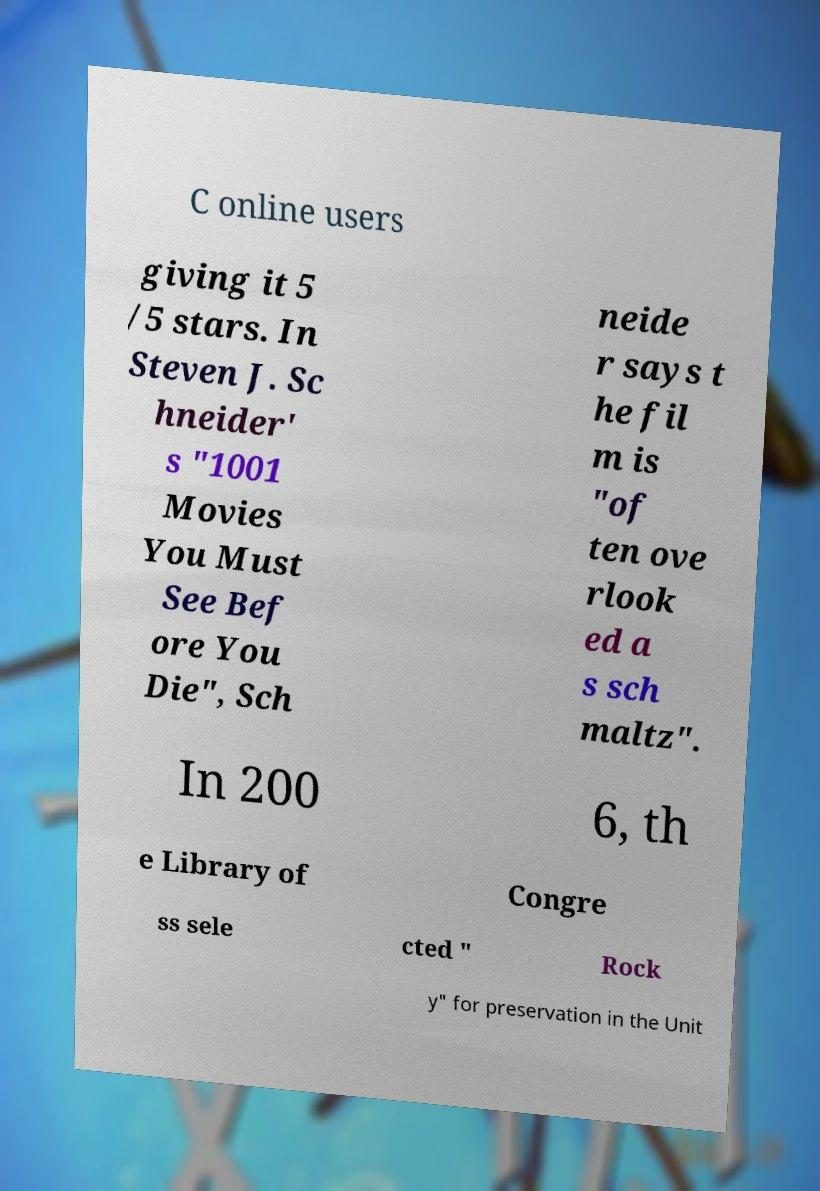There's text embedded in this image that I need extracted. Can you transcribe it verbatim? C online users giving it 5 /5 stars. In Steven J. Sc hneider' s "1001 Movies You Must See Bef ore You Die", Sch neide r says t he fil m is "of ten ove rlook ed a s sch maltz". In 200 6, th e Library of Congre ss sele cted " Rock y" for preservation in the Unit 